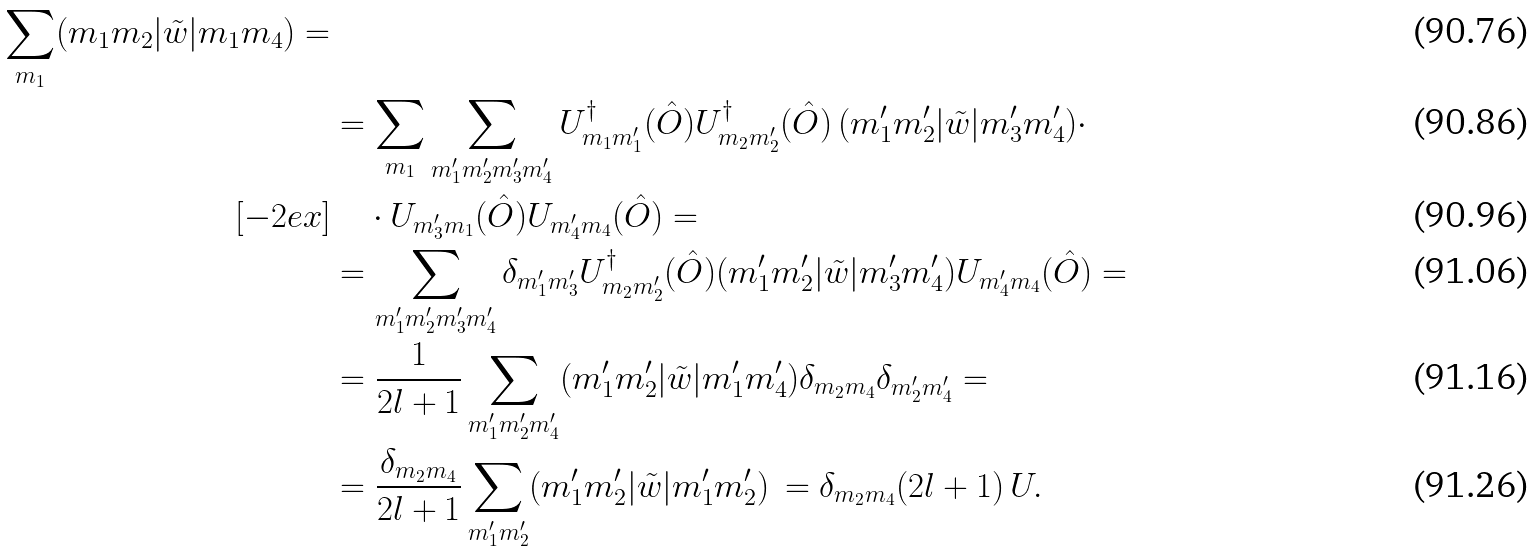<formula> <loc_0><loc_0><loc_500><loc_500>{ \sum _ { m _ { 1 } } ( m _ { 1 } m _ { 2 } | \tilde { w } | m _ { 1 } m _ { 4 } ) = } & \\ & = \sum _ { m _ { 1 } } \sum _ { m ^ { \prime } _ { 1 } m ^ { \prime } _ { 2 } m ^ { \prime } _ { 3 } m ^ { \prime } _ { 4 } } U ^ { \dagger } _ { m _ { 1 } m ^ { \prime } _ { 1 } } ( \hat { O } ) U ^ { \dagger } _ { m _ { 2 } m ^ { \prime } _ { 2 } } ( \hat { O } ) \, ( m ^ { \prime } _ { 1 } m ^ { \prime } _ { 2 } | \tilde { w } | m ^ { \prime } _ { 3 } m ^ { \prime } _ { 4 } ) \cdot \\ [ - 2 e x ] & \quad \cdot U _ { m ^ { \prime } _ { 3 } m _ { 1 } } ( \hat { O } ) U _ { m ^ { \prime } _ { 4 } m _ { 4 } } ( \hat { O } ) = \\ & = \sum _ { m ^ { \prime } _ { 1 } m ^ { \prime } _ { 2 } m ^ { \prime } _ { 3 } m ^ { \prime } _ { 4 } } \delta _ { m ^ { \prime } _ { 1 } m ^ { \prime } _ { 3 } } U ^ { \dagger } _ { m _ { 2 } m ^ { \prime } _ { 2 } } ( \hat { O } ) ( m ^ { \prime } _ { 1 } m ^ { \prime } _ { 2 } | \tilde { w } | m ^ { \prime } _ { 3 } m ^ { \prime } _ { 4 } ) U _ { m ^ { \prime } _ { 4 } m _ { 4 } } ( \hat { O } ) = \\ & = \frac { 1 } { 2 l + 1 } \sum _ { m ^ { \prime } _ { 1 } m ^ { \prime } _ { 2 } m ^ { \prime } _ { 4 } } ( m ^ { \prime } _ { 1 } m ^ { \prime } _ { 2 } | \tilde { w } | m ^ { \prime } _ { 1 } m ^ { \prime } _ { 4 } ) \delta _ { m _ { 2 } m _ { 4 } } \delta _ { m ^ { \prime } _ { 2 } m ^ { \prime } _ { 4 } } = \\ & = \frac { \delta _ { m _ { 2 } m _ { 4 } } } { 2 l + 1 } \sum _ { m ^ { \prime } _ { 1 } m ^ { \prime } _ { 2 } } ( m ^ { \prime } _ { 1 } m ^ { \prime } _ { 2 } | \tilde { w } | m ^ { \prime } _ { 1 } m ^ { \prime } _ { 2 } ) \, = \delta _ { m _ { 2 } m _ { 4 } } ( 2 l + 1 ) \, U .</formula> 